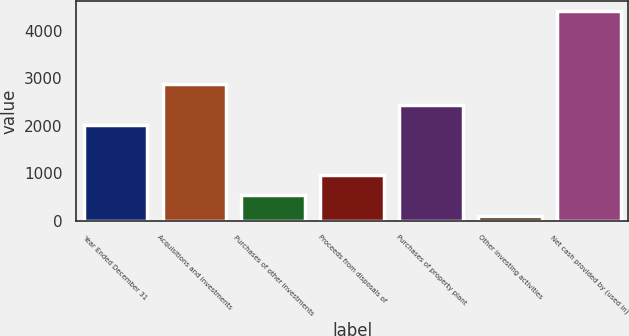<chart> <loc_0><loc_0><loc_500><loc_500><bar_chart><fcel>Year Ended December 31<fcel>Acquisitions and investments<fcel>Purchases of other investments<fcel>Proceeds from disposals of<fcel>Purchases of property plant<fcel>Other investing activities<fcel>Net cash provided by (used in)<nl><fcel>2010<fcel>2869.8<fcel>535.9<fcel>965.8<fcel>2439.9<fcel>106<fcel>4405<nl></chart> 